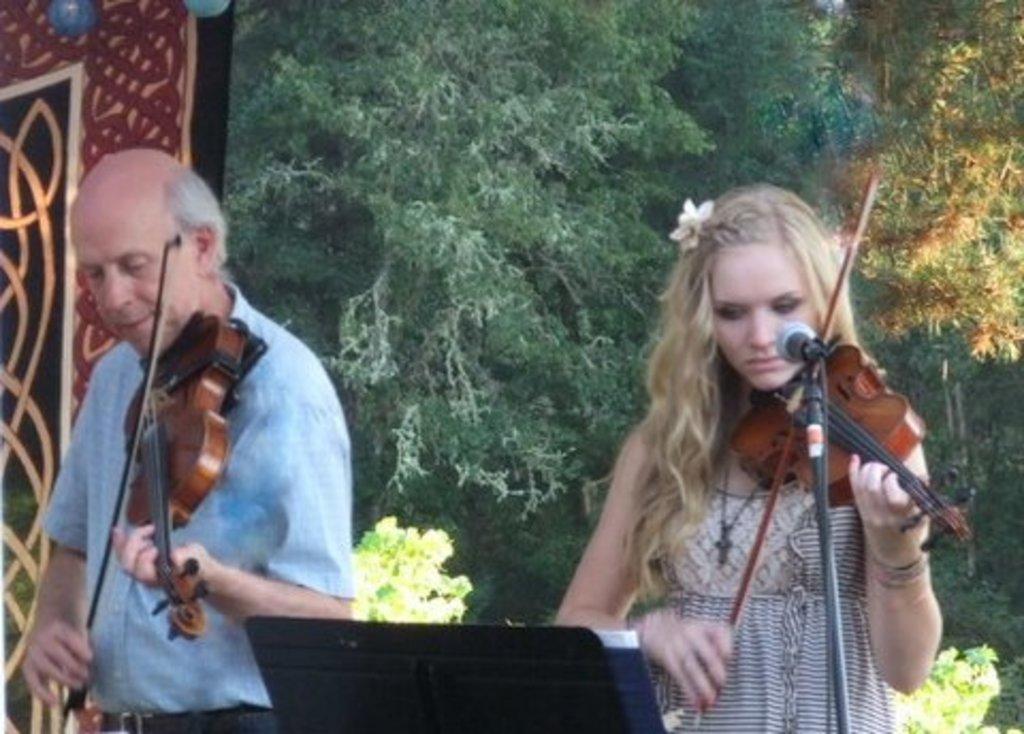Could you give a brief overview of what you see in this image? In this picture we can see two people, here we can see musical instruments and some objects and in the background we can see trees. 